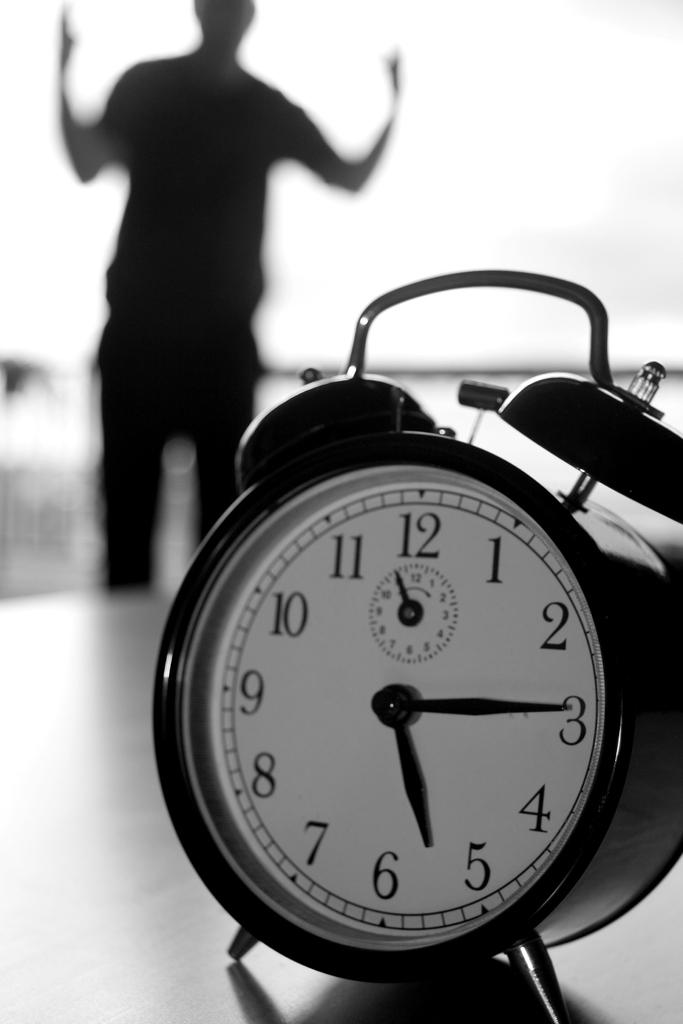<image>
Summarize the visual content of the image. The clock says it is five fifteen as someone shouts at it in the background. 